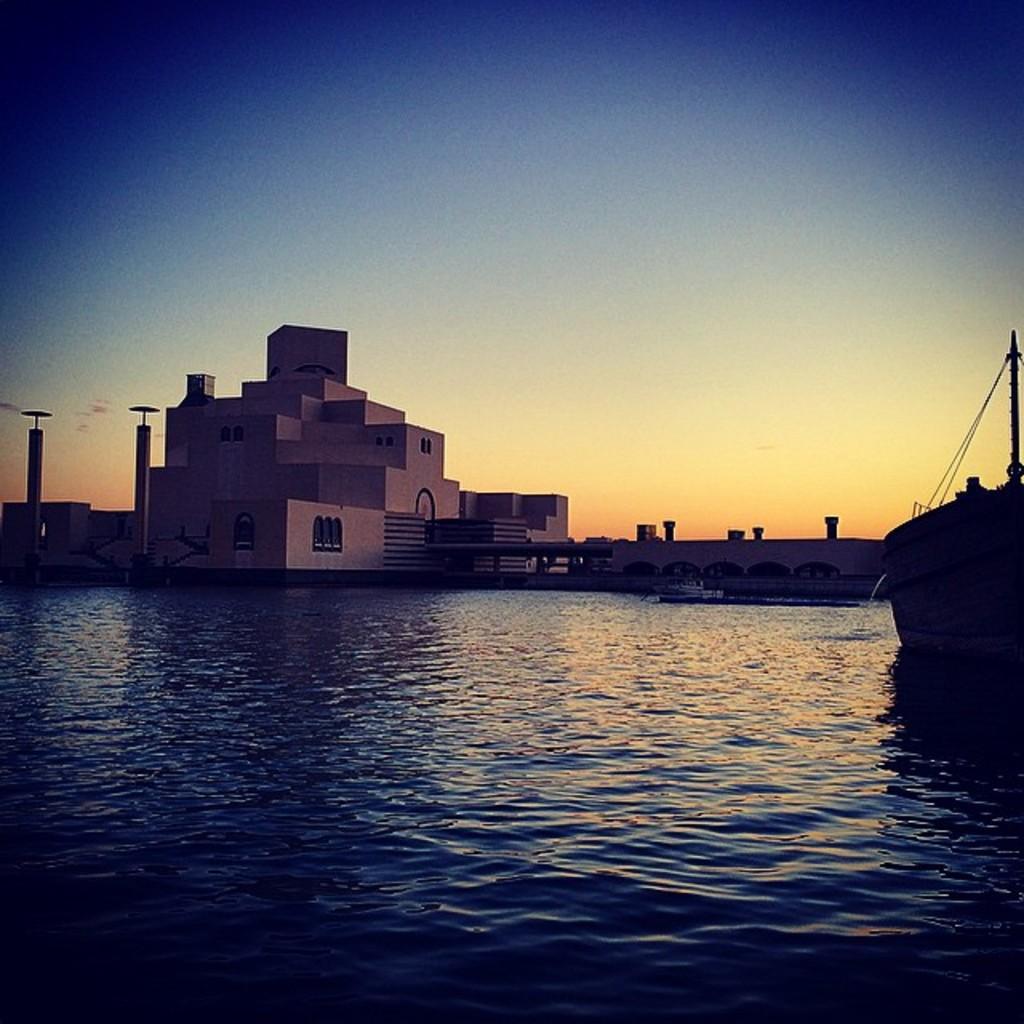Can you describe this image briefly? In the foreground I can see a boat in the water. In the background I can see a building, bridge and poles. On the top I can see the sky. This image is taken in the evening. 